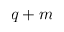<formula> <loc_0><loc_0><loc_500><loc_500>q + m</formula> 